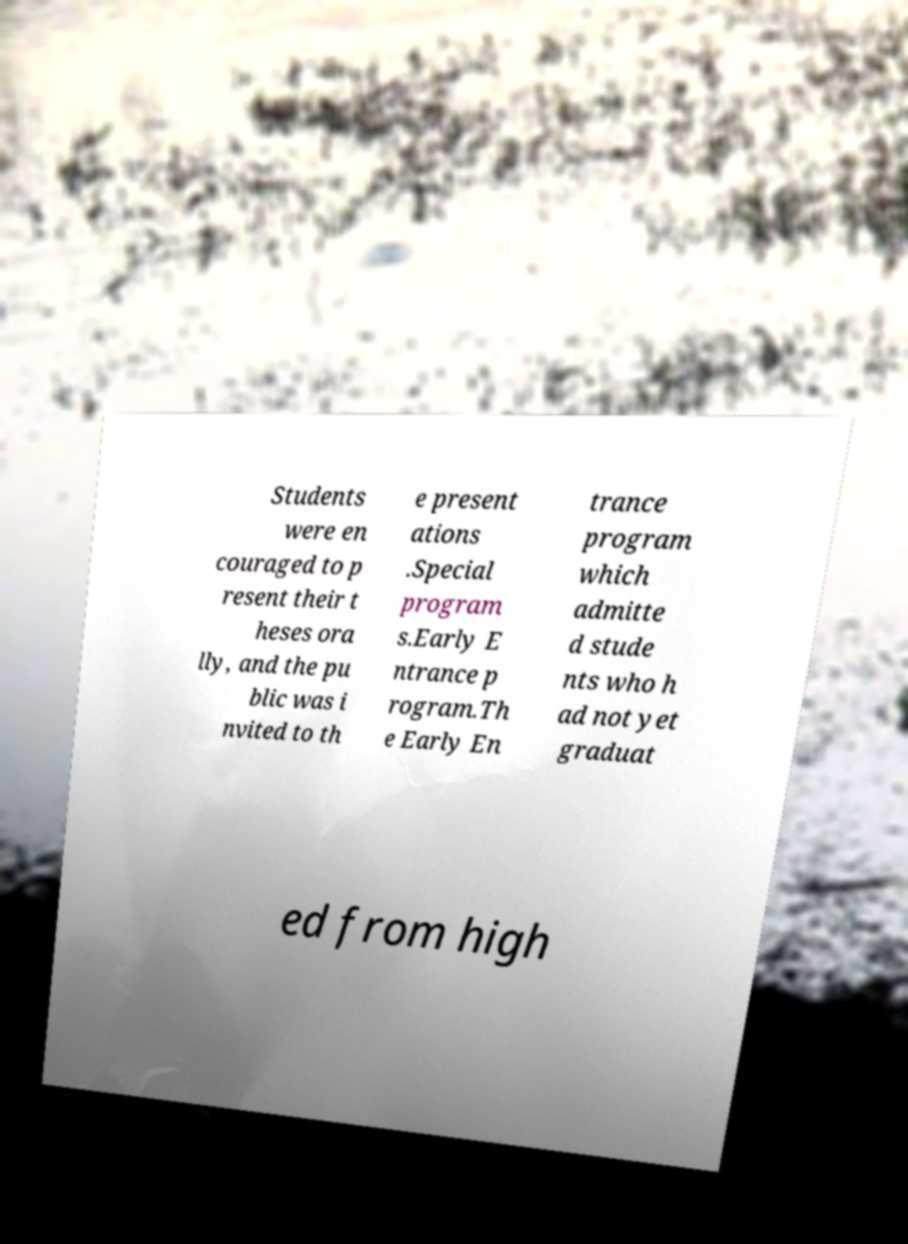What messages or text are displayed in this image? I need them in a readable, typed format. Students were en couraged to p resent their t heses ora lly, and the pu blic was i nvited to th e present ations .Special program s.Early E ntrance p rogram.Th e Early En trance program which admitte d stude nts who h ad not yet graduat ed from high 